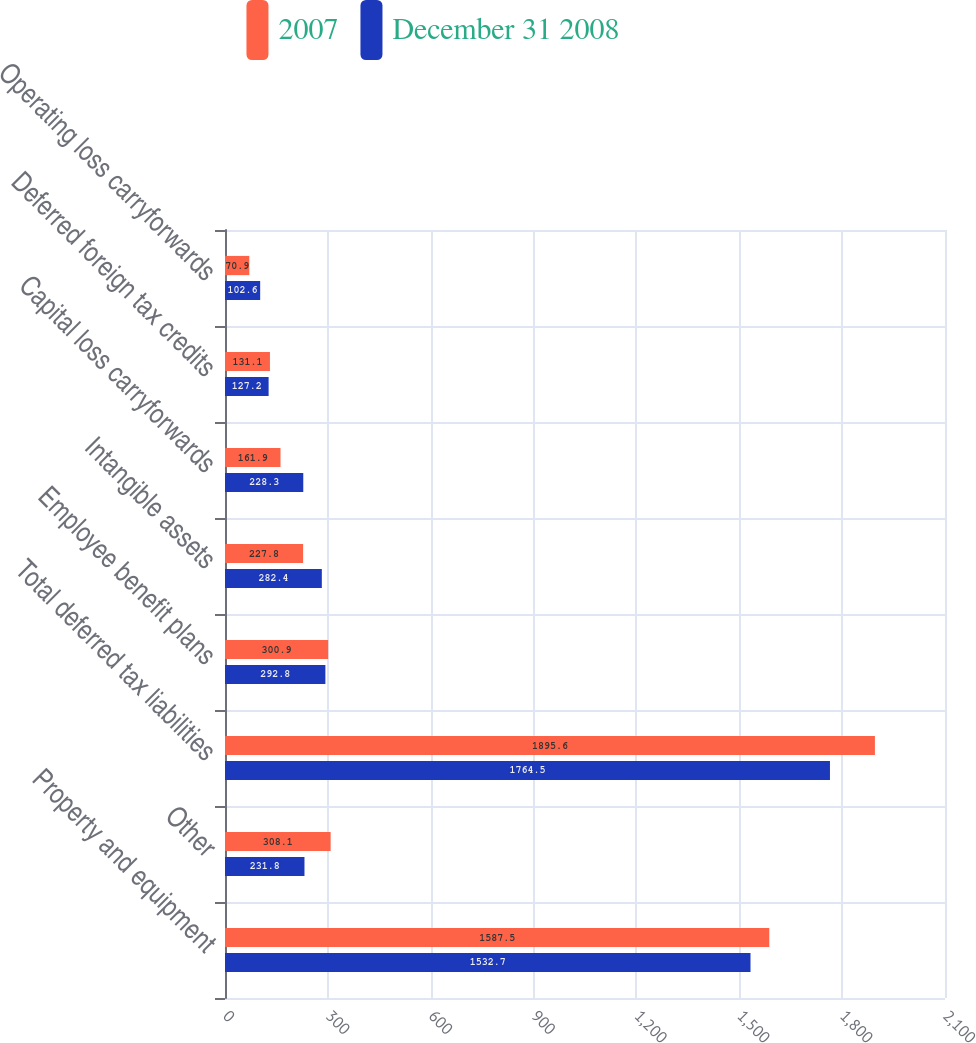Convert chart to OTSL. <chart><loc_0><loc_0><loc_500><loc_500><stacked_bar_chart><ecel><fcel>Property and equipment<fcel>Other<fcel>Total deferred tax liabilities<fcel>Employee benefit plans<fcel>Intangible assets<fcel>Capital loss carryforwards<fcel>Deferred foreign tax credits<fcel>Operating loss carryforwards<nl><fcel>2007<fcel>1587.5<fcel>308.1<fcel>1895.6<fcel>300.9<fcel>227.8<fcel>161.9<fcel>131.1<fcel>70.9<nl><fcel>December 31 2008<fcel>1532.7<fcel>231.8<fcel>1764.5<fcel>292.8<fcel>282.4<fcel>228.3<fcel>127.2<fcel>102.6<nl></chart> 